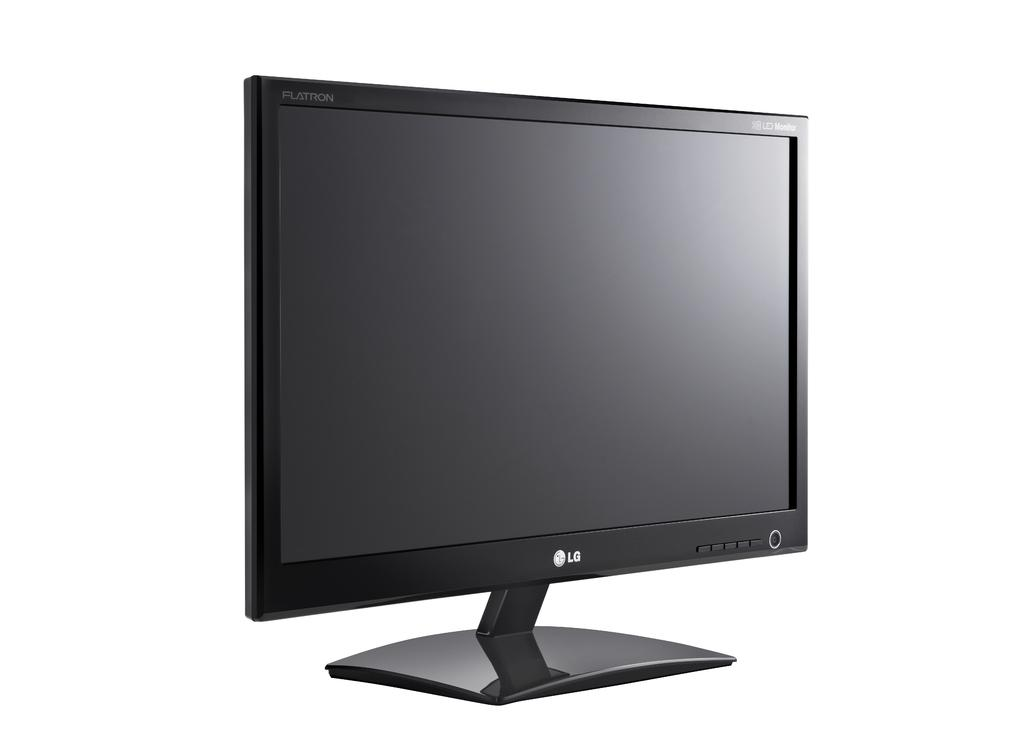<image>
Provide a brief description of the given image. A large flat screen LG TV with the power turned off. 